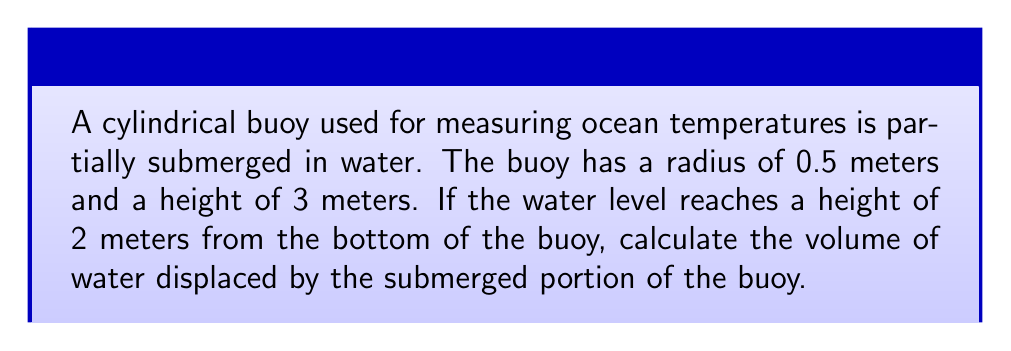Can you answer this question? To solve this problem, we'll use the disk method of integration to calculate the volume of the submerged portion of the cylindrical buoy.

Step 1: Set up the integral
The volume of a solid of revolution can be calculated using the formula:
$$V = \int_a^b \pi r(x)^2 dx$$
Where $r(x)$ is the radius of the cross-section at height $x$.

In this case, the radius is constant (0.5 meters), so our integral becomes:
$$V = \int_0^2 \pi (0.5)^2 dx$$

Step 2: Simplify the integral
$$V = \pi (0.5)^2 \int_0^2 dx$$
$$V = \frac{\pi}{4} \int_0^2 dx$$

Step 3: Evaluate the integral
$$V = \frac{\pi}{4} [x]_0^2$$
$$V = \frac{\pi}{4} (2 - 0)$$
$$V = \frac{\pi}{2}$$

Step 4: Calculate the final volume
$$V = \frac{\pi}{2} \approx 1.5708 \text{ m}^3$$

Therefore, the volume of water displaced by the submerged portion of the buoy is approximately 1.5708 cubic meters.
Answer: $\frac{\pi}{2} \text{ m}^3$ or approximately 1.5708 $\text{m}^3$ 